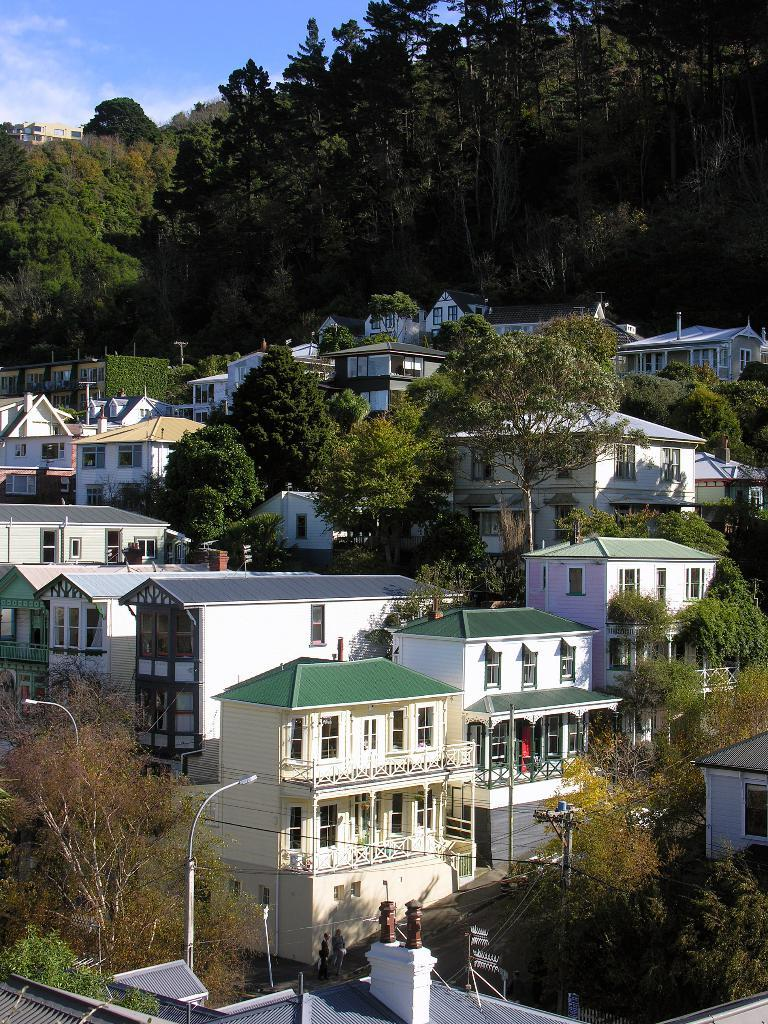What types of structures can be seen in the image? There are many buildings in the image. What type of vegetation is present in the image? There are many trees in the image. What is the weight of the mine in the image? There is no mine present in the image, so it is not possible to determine its weight. 